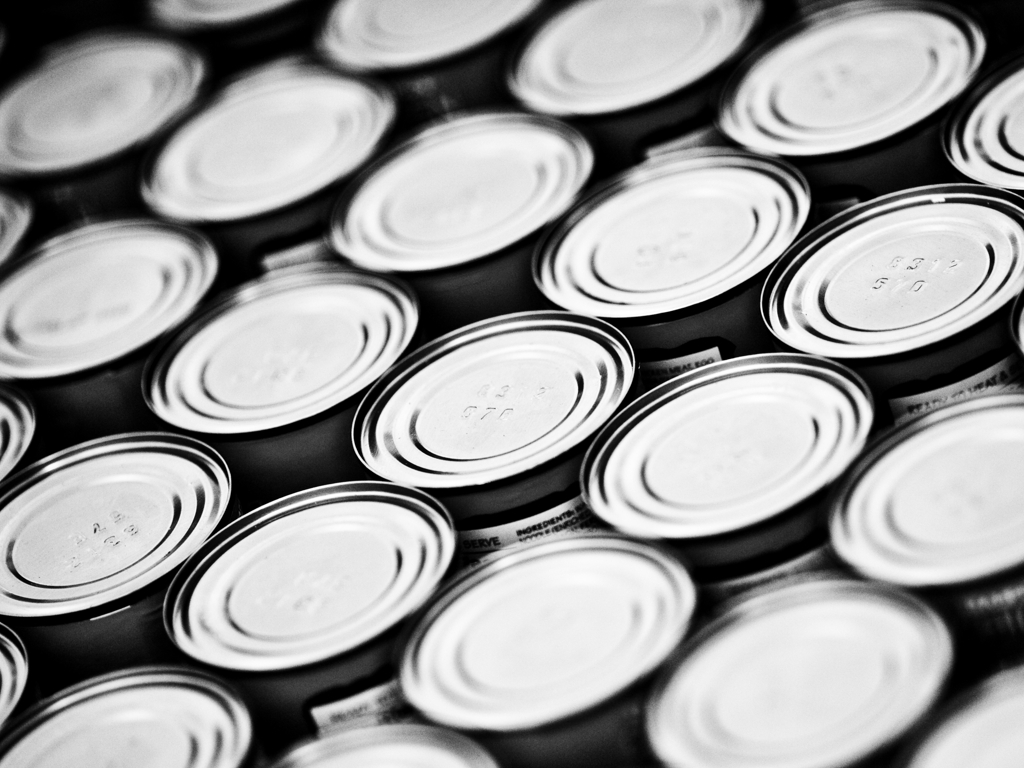What might these round objects be used for? The round objects in the image appear to be lids for cans or containers. They are typically used for sealing products such as food, beverages, or other consumable goods to preserve their quality and prevent contamination. Are all the lids identical or are there variations among them? While they may look identical at first glance, upon closer observation, one can sometimes find slight variations such as different batch codes, minor differences in the shape or design due to manufacturing processes, or even small dents and scratches that distinguish one lid from another. 